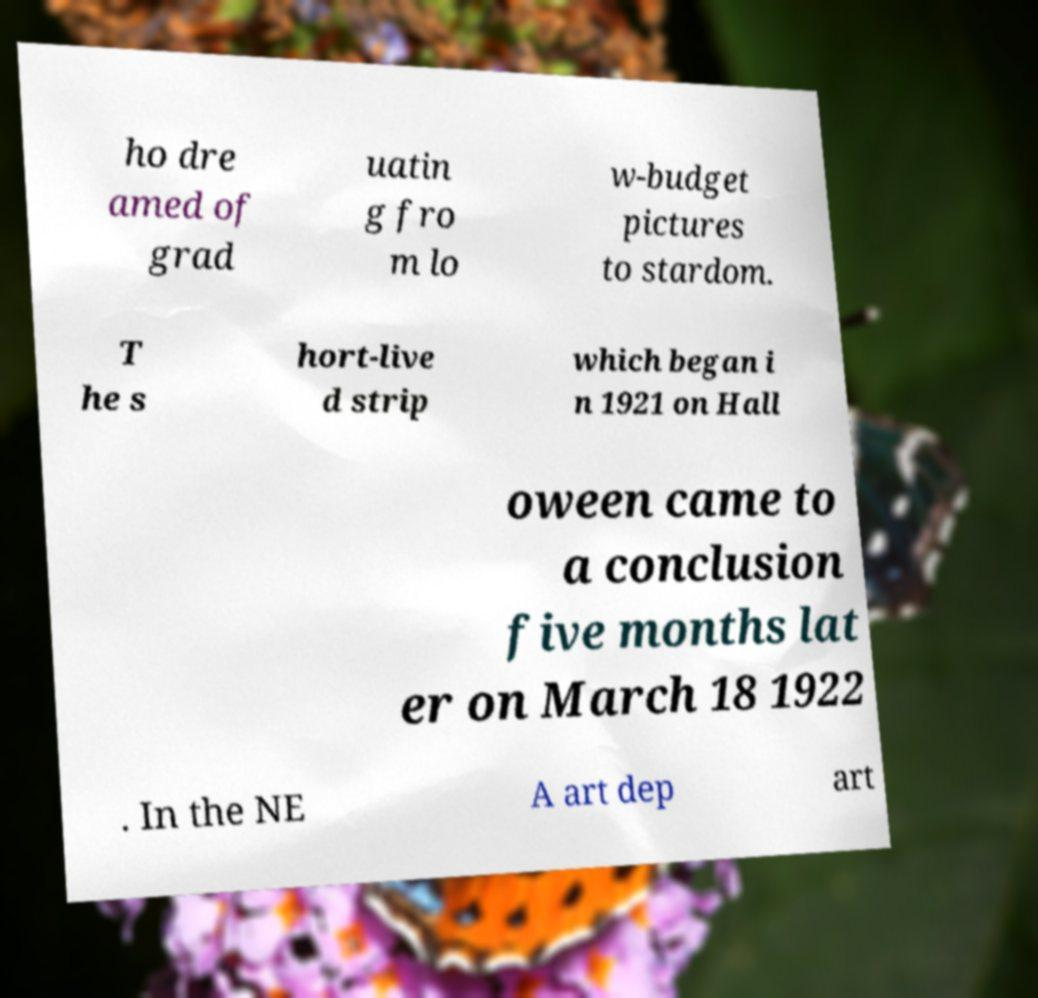Can you accurately transcribe the text from the provided image for me? ho dre amed of grad uatin g fro m lo w-budget pictures to stardom. T he s hort-live d strip which began i n 1921 on Hall oween came to a conclusion five months lat er on March 18 1922 . In the NE A art dep art 